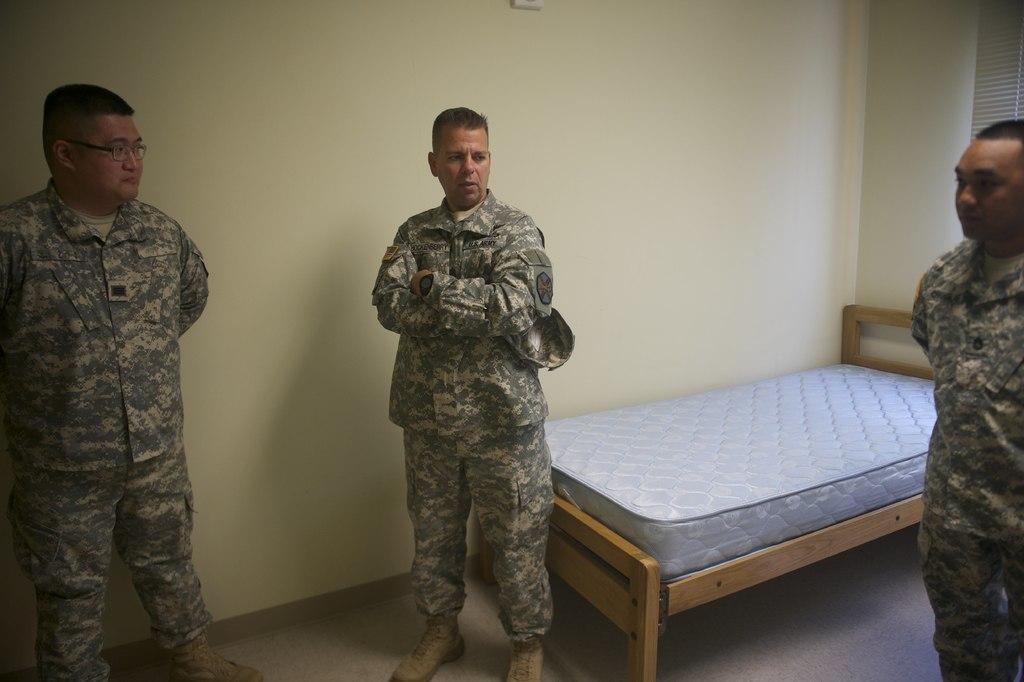How many people are present in the image? There are three persons standing in the image. What is located behind the persons? There is a bed behind the persons. What color is the background wall in the image? The background wall is cream in color. Can you see any twigs on the persons in the image? There are no twigs visible on the persons in the image. What type of hill is visible in the background of the image? There is no hill visible in the background of the image; it features a cream-colored wall. 